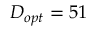Convert formula to latex. <formula><loc_0><loc_0><loc_500><loc_500>D _ { o p t } = 5 1</formula> 